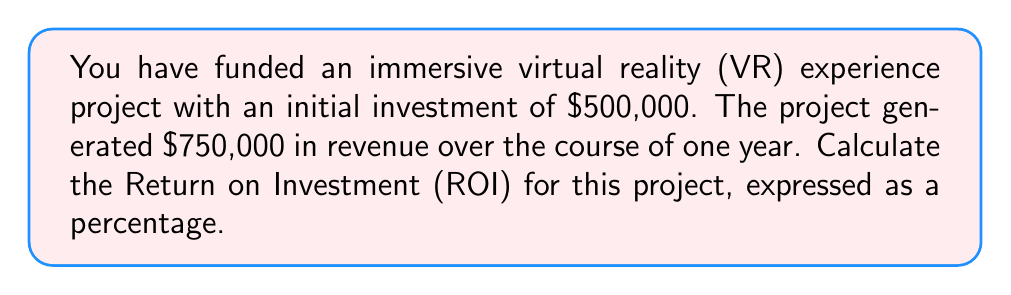Could you help me with this problem? To calculate the Return on Investment (ROI), we need to follow these steps:

1. Calculate the net profit:
   Net profit = Revenue - Initial investment
   $$ \text{Net profit} = \$750,000 - \$500,000 = \$250,000 $$

2. Use the ROI formula:
   $$ \text{ROI} = \frac{\text{Net profit}}{\text{Initial investment}} \times 100\% $$

3. Plug in the values:
   $$ \text{ROI} = \frac{\$250,000}{\$500,000} \times 100\% $$

4. Perform the calculation:
   $$ \text{ROI} = 0.5 \times 100\% = 50\% $$

The ROI is expressed as a percentage, so our final answer is 50%.
Answer: 50% 